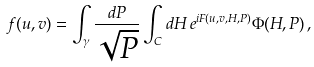<formula> <loc_0><loc_0><loc_500><loc_500>f ( u , v ) = \int _ { \gamma } \frac { d P } { \sqrt { P } } \int _ { C } d H \, e ^ { i F ( u , v , H , P ) } \Phi ( H , P ) \, ,</formula> 